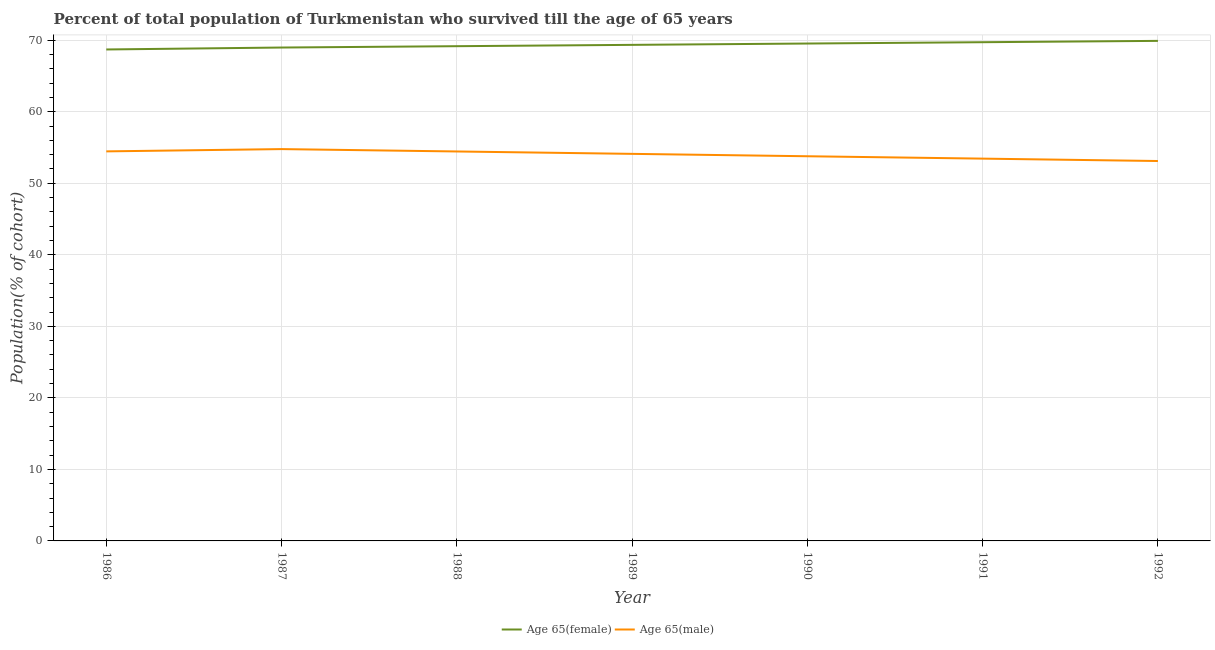Does the line corresponding to percentage of female population who survived till age of 65 intersect with the line corresponding to percentage of male population who survived till age of 65?
Your response must be concise. No. Is the number of lines equal to the number of legend labels?
Make the answer very short. Yes. What is the percentage of female population who survived till age of 65 in 1992?
Your response must be concise. 69.91. Across all years, what is the maximum percentage of male population who survived till age of 65?
Your answer should be very brief. 54.78. Across all years, what is the minimum percentage of male population who survived till age of 65?
Offer a very short reply. 53.11. What is the total percentage of male population who survived till age of 65 in the graph?
Keep it short and to the point. 378.15. What is the difference between the percentage of male population who survived till age of 65 in 1988 and that in 1991?
Keep it short and to the point. 1. What is the difference between the percentage of female population who survived till age of 65 in 1991 and the percentage of male population who survived till age of 65 in 1986?
Your answer should be compact. 15.26. What is the average percentage of male population who survived till age of 65 per year?
Provide a succinct answer. 54.02. In the year 1987, what is the difference between the percentage of female population who survived till age of 65 and percentage of male population who survived till age of 65?
Offer a very short reply. 14.2. In how many years, is the percentage of female population who survived till age of 65 greater than 26 %?
Offer a terse response. 7. What is the ratio of the percentage of female population who survived till age of 65 in 1988 to that in 1990?
Keep it short and to the point. 0.99. What is the difference between the highest and the second highest percentage of female population who survived till age of 65?
Make the answer very short. 0.19. What is the difference between the highest and the lowest percentage of female population who survived till age of 65?
Offer a terse response. 1.2. In how many years, is the percentage of male population who survived till age of 65 greater than the average percentage of male population who survived till age of 65 taken over all years?
Your answer should be very brief. 4. Is the sum of the percentage of male population who survived till age of 65 in 1988 and 1989 greater than the maximum percentage of female population who survived till age of 65 across all years?
Ensure brevity in your answer.  Yes. Does the percentage of male population who survived till age of 65 monotonically increase over the years?
Give a very brief answer. No. Is the percentage of male population who survived till age of 65 strictly greater than the percentage of female population who survived till age of 65 over the years?
Your answer should be very brief. No. Are the values on the major ticks of Y-axis written in scientific E-notation?
Make the answer very short. No. How are the legend labels stacked?
Offer a terse response. Horizontal. What is the title of the graph?
Provide a succinct answer. Percent of total population of Turkmenistan who survived till the age of 65 years. Does "Secondary education" appear as one of the legend labels in the graph?
Offer a terse response. No. What is the label or title of the Y-axis?
Your answer should be compact. Population(% of cohort). What is the Population(% of cohort) in Age 65(female) in 1986?
Give a very brief answer. 68.71. What is the Population(% of cohort) in Age 65(male) in 1986?
Keep it short and to the point. 54.46. What is the Population(% of cohort) of Age 65(female) in 1987?
Keep it short and to the point. 68.98. What is the Population(% of cohort) in Age 65(male) in 1987?
Provide a succinct answer. 54.78. What is the Population(% of cohort) in Age 65(female) in 1988?
Make the answer very short. 69.17. What is the Population(% of cohort) of Age 65(male) in 1988?
Your response must be concise. 54.45. What is the Population(% of cohort) in Age 65(female) in 1989?
Offer a terse response. 69.35. What is the Population(% of cohort) in Age 65(male) in 1989?
Keep it short and to the point. 54.12. What is the Population(% of cohort) in Age 65(female) in 1990?
Your answer should be very brief. 69.54. What is the Population(% of cohort) of Age 65(male) in 1990?
Keep it short and to the point. 53.78. What is the Population(% of cohort) in Age 65(female) in 1991?
Offer a very short reply. 69.72. What is the Population(% of cohort) of Age 65(male) in 1991?
Keep it short and to the point. 53.45. What is the Population(% of cohort) of Age 65(female) in 1992?
Keep it short and to the point. 69.91. What is the Population(% of cohort) in Age 65(male) in 1992?
Provide a short and direct response. 53.11. Across all years, what is the maximum Population(% of cohort) of Age 65(female)?
Your response must be concise. 69.91. Across all years, what is the maximum Population(% of cohort) of Age 65(male)?
Ensure brevity in your answer.  54.78. Across all years, what is the minimum Population(% of cohort) of Age 65(female)?
Keep it short and to the point. 68.71. Across all years, what is the minimum Population(% of cohort) of Age 65(male)?
Your answer should be very brief. 53.11. What is the total Population(% of cohort) of Age 65(female) in the graph?
Give a very brief answer. 485.39. What is the total Population(% of cohort) of Age 65(male) in the graph?
Ensure brevity in your answer.  378.15. What is the difference between the Population(% of cohort) of Age 65(female) in 1986 and that in 1987?
Give a very brief answer. -0.27. What is the difference between the Population(% of cohort) of Age 65(male) in 1986 and that in 1987?
Offer a very short reply. -0.32. What is the difference between the Population(% of cohort) in Age 65(female) in 1986 and that in 1988?
Keep it short and to the point. -0.46. What is the difference between the Population(% of cohort) of Age 65(male) in 1986 and that in 1988?
Your answer should be compact. 0.01. What is the difference between the Population(% of cohort) of Age 65(female) in 1986 and that in 1989?
Your answer should be very brief. -0.64. What is the difference between the Population(% of cohort) of Age 65(male) in 1986 and that in 1989?
Keep it short and to the point. 0.35. What is the difference between the Population(% of cohort) of Age 65(female) in 1986 and that in 1990?
Offer a very short reply. -0.83. What is the difference between the Population(% of cohort) in Age 65(male) in 1986 and that in 1990?
Keep it short and to the point. 0.68. What is the difference between the Population(% of cohort) of Age 65(female) in 1986 and that in 1991?
Give a very brief answer. -1.01. What is the difference between the Population(% of cohort) of Age 65(male) in 1986 and that in 1991?
Keep it short and to the point. 1.02. What is the difference between the Population(% of cohort) in Age 65(female) in 1986 and that in 1992?
Offer a terse response. -1.2. What is the difference between the Population(% of cohort) in Age 65(male) in 1986 and that in 1992?
Your response must be concise. 1.35. What is the difference between the Population(% of cohort) in Age 65(female) in 1987 and that in 1988?
Your answer should be compact. -0.19. What is the difference between the Population(% of cohort) of Age 65(male) in 1987 and that in 1988?
Keep it short and to the point. 0.33. What is the difference between the Population(% of cohort) of Age 65(female) in 1987 and that in 1989?
Offer a terse response. -0.37. What is the difference between the Population(% of cohort) in Age 65(male) in 1987 and that in 1989?
Make the answer very short. 0.67. What is the difference between the Population(% of cohort) of Age 65(female) in 1987 and that in 1990?
Keep it short and to the point. -0.56. What is the difference between the Population(% of cohort) in Age 65(female) in 1987 and that in 1991?
Give a very brief answer. -0.74. What is the difference between the Population(% of cohort) of Age 65(male) in 1987 and that in 1991?
Provide a succinct answer. 1.33. What is the difference between the Population(% of cohort) of Age 65(female) in 1987 and that in 1992?
Keep it short and to the point. -0.93. What is the difference between the Population(% of cohort) in Age 65(male) in 1987 and that in 1992?
Give a very brief answer. 1.67. What is the difference between the Population(% of cohort) of Age 65(female) in 1988 and that in 1989?
Offer a very short reply. -0.19. What is the difference between the Population(% of cohort) of Age 65(male) in 1988 and that in 1989?
Your response must be concise. 0.33. What is the difference between the Population(% of cohort) in Age 65(female) in 1988 and that in 1990?
Offer a very short reply. -0.37. What is the difference between the Population(% of cohort) of Age 65(male) in 1988 and that in 1990?
Your answer should be compact. 0.67. What is the difference between the Population(% of cohort) of Age 65(female) in 1988 and that in 1991?
Your response must be concise. -0.56. What is the difference between the Population(% of cohort) of Age 65(female) in 1988 and that in 1992?
Provide a short and direct response. -0.74. What is the difference between the Population(% of cohort) of Age 65(male) in 1988 and that in 1992?
Offer a very short reply. 1.33. What is the difference between the Population(% of cohort) in Age 65(female) in 1989 and that in 1990?
Offer a terse response. -0.19. What is the difference between the Population(% of cohort) in Age 65(male) in 1989 and that in 1990?
Your response must be concise. 0.33. What is the difference between the Population(% of cohort) in Age 65(female) in 1989 and that in 1991?
Provide a succinct answer. -0.37. What is the difference between the Population(% of cohort) of Age 65(male) in 1989 and that in 1991?
Provide a succinct answer. 0.67. What is the difference between the Population(% of cohort) of Age 65(female) in 1989 and that in 1992?
Offer a terse response. -0.56. What is the difference between the Population(% of cohort) in Age 65(female) in 1990 and that in 1991?
Ensure brevity in your answer.  -0.19. What is the difference between the Population(% of cohort) in Age 65(male) in 1990 and that in 1991?
Give a very brief answer. 0.33. What is the difference between the Population(% of cohort) in Age 65(female) in 1990 and that in 1992?
Offer a terse response. -0.37. What is the difference between the Population(% of cohort) in Age 65(male) in 1990 and that in 1992?
Offer a very short reply. 0.67. What is the difference between the Population(% of cohort) of Age 65(female) in 1991 and that in 1992?
Provide a short and direct response. -0.19. What is the difference between the Population(% of cohort) in Age 65(male) in 1991 and that in 1992?
Your answer should be very brief. 0.33. What is the difference between the Population(% of cohort) in Age 65(female) in 1986 and the Population(% of cohort) in Age 65(male) in 1987?
Your answer should be compact. 13.93. What is the difference between the Population(% of cohort) of Age 65(female) in 1986 and the Population(% of cohort) of Age 65(male) in 1988?
Provide a short and direct response. 14.26. What is the difference between the Population(% of cohort) of Age 65(female) in 1986 and the Population(% of cohort) of Age 65(male) in 1989?
Give a very brief answer. 14.6. What is the difference between the Population(% of cohort) of Age 65(female) in 1986 and the Population(% of cohort) of Age 65(male) in 1990?
Give a very brief answer. 14.93. What is the difference between the Population(% of cohort) of Age 65(female) in 1986 and the Population(% of cohort) of Age 65(male) in 1991?
Provide a short and direct response. 15.26. What is the difference between the Population(% of cohort) in Age 65(female) in 1986 and the Population(% of cohort) in Age 65(male) in 1992?
Provide a short and direct response. 15.6. What is the difference between the Population(% of cohort) of Age 65(female) in 1987 and the Population(% of cohort) of Age 65(male) in 1988?
Make the answer very short. 14.53. What is the difference between the Population(% of cohort) in Age 65(female) in 1987 and the Population(% of cohort) in Age 65(male) in 1989?
Provide a short and direct response. 14.87. What is the difference between the Population(% of cohort) in Age 65(female) in 1987 and the Population(% of cohort) in Age 65(male) in 1990?
Offer a very short reply. 15.2. What is the difference between the Population(% of cohort) in Age 65(female) in 1987 and the Population(% of cohort) in Age 65(male) in 1991?
Your answer should be very brief. 15.53. What is the difference between the Population(% of cohort) in Age 65(female) in 1987 and the Population(% of cohort) in Age 65(male) in 1992?
Make the answer very short. 15.87. What is the difference between the Population(% of cohort) of Age 65(female) in 1988 and the Population(% of cohort) of Age 65(male) in 1989?
Provide a short and direct response. 15.05. What is the difference between the Population(% of cohort) in Age 65(female) in 1988 and the Population(% of cohort) in Age 65(male) in 1990?
Offer a terse response. 15.39. What is the difference between the Population(% of cohort) in Age 65(female) in 1988 and the Population(% of cohort) in Age 65(male) in 1991?
Your response must be concise. 15.72. What is the difference between the Population(% of cohort) of Age 65(female) in 1988 and the Population(% of cohort) of Age 65(male) in 1992?
Make the answer very short. 16.05. What is the difference between the Population(% of cohort) of Age 65(female) in 1989 and the Population(% of cohort) of Age 65(male) in 1990?
Your answer should be compact. 15.57. What is the difference between the Population(% of cohort) in Age 65(female) in 1989 and the Population(% of cohort) in Age 65(male) in 1991?
Provide a succinct answer. 15.91. What is the difference between the Population(% of cohort) in Age 65(female) in 1989 and the Population(% of cohort) in Age 65(male) in 1992?
Make the answer very short. 16.24. What is the difference between the Population(% of cohort) in Age 65(female) in 1990 and the Population(% of cohort) in Age 65(male) in 1991?
Your answer should be compact. 16.09. What is the difference between the Population(% of cohort) in Age 65(female) in 1990 and the Population(% of cohort) in Age 65(male) in 1992?
Your answer should be compact. 16.42. What is the difference between the Population(% of cohort) in Age 65(female) in 1991 and the Population(% of cohort) in Age 65(male) in 1992?
Your answer should be very brief. 16.61. What is the average Population(% of cohort) in Age 65(female) per year?
Ensure brevity in your answer.  69.34. What is the average Population(% of cohort) in Age 65(male) per year?
Provide a succinct answer. 54.02. In the year 1986, what is the difference between the Population(% of cohort) in Age 65(female) and Population(% of cohort) in Age 65(male)?
Your response must be concise. 14.25. In the year 1987, what is the difference between the Population(% of cohort) of Age 65(female) and Population(% of cohort) of Age 65(male)?
Your answer should be very brief. 14.2. In the year 1988, what is the difference between the Population(% of cohort) of Age 65(female) and Population(% of cohort) of Age 65(male)?
Ensure brevity in your answer.  14.72. In the year 1989, what is the difference between the Population(% of cohort) of Age 65(female) and Population(% of cohort) of Age 65(male)?
Offer a very short reply. 15.24. In the year 1990, what is the difference between the Population(% of cohort) in Age 65(female) and Population(% of cohort) in Age 65(male)?
Provide a short and direct response. 15.76. In the year 1991, what is the difference between the Population(% of cohort) of Age 65(female) and Population(% of cohort) of Age 65(male)?
Your answer should be compact. 16.28. In the year 1992, what is the difference between the Population(% of cohort) in Age 65(female) and Population(% of cohort) in Age 65(male)?
Provide a short and direct response. 16.8. What is the ratio of the Population(% of cohort) of Age 65(female) in 1986 to that in 1987?
Give a very brief answer. 1. What is the ratio of the Population(% of cohort) of Age 65(female) in 1986 to that in 1988?
Ensure brevity in your answer.  0.99. What is the ratio of the Population(% of cohort) in Age 65(female) in 1986 to that in 1989?
Keep it short and to the point. 0.99. What is the ratio of the Population(% of cohort) of Age 65(male) in 1986 to that in 1989?
Provide a short and direct response. 1.01. What is the ratio of the Population(% of cohort) in Age 65(female) in 1986 to that in 1990?
Provide a succinct answer. 0.99. What is the ratio of the Population(% of cohort) of Age 65(male) in 1986 to that in 1990?
Give a very brief answer. 1.01. What is the ratio of the Population(% of cohort) of Age 65(female) in 1986 to that in 1991?
Your answer should be compact. 0.99. What is the ratio of the Population(% of cohort) in Age 65(female) in 1986 to that in 1992?
Offer a very short reply. 0.98. What is the ratio of the Population(% of cohort) of Age 65(male) in 1986 to that in 1992?
Provide a succinct answer. 1.03. What is the ratio of the Population(% of cohort) in Age 65(male) in 1987 to that in 1988?
Give a very brief answer. 1.01. What is the ratio of the Population(% of cohort) of Age 65(male) in 1987 to that in 1989?
Your answer should be compact. 1.01. What is the ratio of the Population(% of cohort) in Age 65(female) in 1987 to that in 1990?
Keep it short and to the point. 0.99. What is the ratio of the Population(% of cohort) in Age 65(male) in 1987 to that in 1990?
Offer a very short reply. 1.02. What is the ratio of the Population(% of cohort) in Age 65(female) in 1987 to that in 1991?
Your response must be concise. 0.99. What is the ratio of the Population(% of cohort) of Age 65(female) in 1987 to that in 1992?
Make the answer very short. 0.99. What is the ratio of the Population(% of cohort) in Age 65(male) in 1987 to that in 1992?
Make the answer very short. 1.03. What is the ratio of the Population(% of cohort) in Age 65(female) in 1988 to that in 1989?
Your answer should be compact. 1. What is the ratio of the Population(% of cohort) of Age 65(male) in 1988 to that in 1989?
Offer a terse response. 1.01. What is the ratio of the Population(% of cohort) of Age 65(male) in 1988 to that in 1990?
Offer a terse response. 1.01. What is the ratio of the Population(% of cohort) in Age 65(male) in 1988 to that in 1991?
Provide a short and direct response. 1.02. What is the ratio of the Population(% of cohort) in Age 65(female) in 1988 to that in 1992?
Provide a short and direct response. 0.99. What is the ratio of the Population(% of cohort) of Age 65(male) in 1988 to that in 1992?
Offer a very short reply. 1.03. What is the ratio of the Population(% of cohort) in Age 65(female) in 1989 to that in 1990?
Offer a terse response. 1. What is the ratio of the Population(% of cohort) of Age 65(male) in 1989 to that in 1990?
Keep it short and to the point. 1.01. What is the ratio of the Population(% of cohort) of Age 65(male) in 1989 to that in 1991?
Your answer should be compact. 1.01. What is the ratio of the Population(% of cohort) of Age 65(female) in 1989 to that in 1992?
Make the answer very short. 0.99. What is the ratio of the Population(% of cohort) in Age 65(male) in 1989 to that in 1992?
Ensure brevity in your answer.  1.02. What is the ratio of the Population(% of cohort) of Age 65(female) in 1990 to that in 1991?
Your answer should be very brief. 1. What is the ratio of the Population(% of cohort) in Age 65(male) in 1990 to that in 1991?
Make the answer very short. 1.01. What is the ratio of the Population(% of cohort) in Age 65(male) in 1990 to that in 1992?
Offer a terse response. 1.01. What is the ratio of the Population(% of cohort) of Age 65(female) in 1991 to that in 1992?
Ensure brevity in your answer.  1. What is the ratio of the Population(% of cohort) in Age 65(male) in 1991 to that in 1992?
Provide a succinct answer. 1.01. What is the difference between the highest and the second highest Population(% of cohort) of Age 65(female)?
Provide a succinct answer. 0.19. What is the difference between the highest and the second highest Population(% of cohort) of Age 65(male)?
Your response must be concise. 0.32. What is the difference between the highest and the lowest Population(% of cohort) in Age 65(female)?
Your answer should be very brief. 1.2. What is the difference between the highest and the lowest Population(% of cohort) in Age 65(male)?
Ensure brevity in your answer.  1.67. 